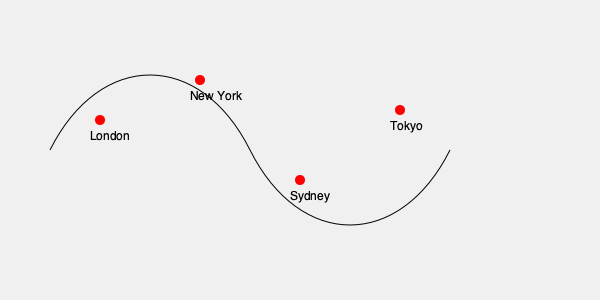Based on Eddie Izzard's global comedy tours, which city represented on this world map is most likely to be the starting point of his "Force Majeure" tour, given his British origins and the tour's record-breaking nature? To answer this question, we need to consider several factors:

1. Eddie Izzard's nationality: He is British, which suggests a strong connection to the UK.

2. The nature of the "Force Majeure" tour: It was a record-breaking world tour, covering 45 countries across 5 continents.

3. The cities shown on the map: London, New York, Sydney, and Tokyo.

4. Common practices for launching world tours: Many artists start their world tours in their home country or city.

5. London's significance: As the capital of the UK and a major global city, it's a logical starting point for a British comedian's world tour.

6. Eddie Izzard's career trajectory: He gained prominence in the UK before expanding his reach globally.

Considering these factors, London is the most likely starting point for the "Force Majeure" tour. It aligns with Eddie's British background, provides a familiar and supportive audience to launch a major tour, and is geographically positioned well for expanding the tour to other continents.
Answer: London 